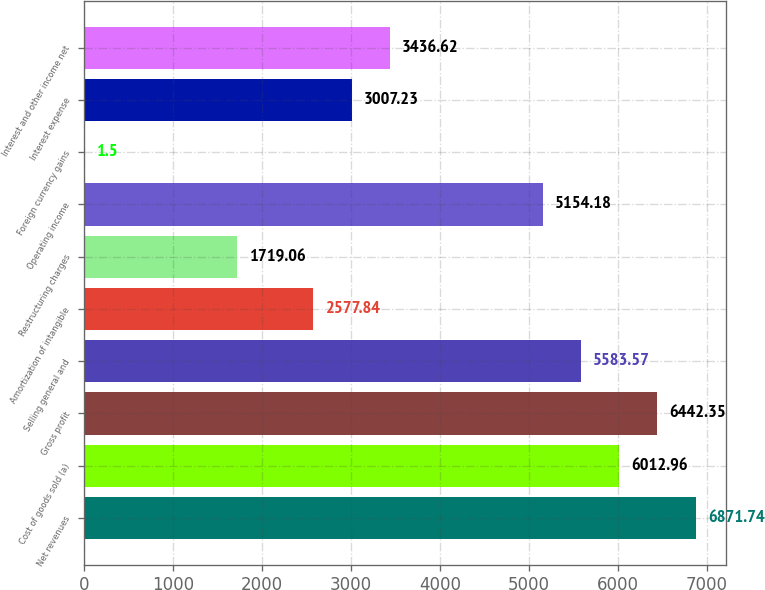Convert chart. <chart><loc_0><loc_0><loc_500><loc_500><bar_chart><fcel>Net revenues<fcel>Cost of goods sold (a)<fcel>Gross profit<fcel>Selling general and<fcel>Amortization of intangible<fcel>Restructuring charges<fcel>Operating income<fcel>Foreign currency gains<fcel>Interest expense<fcel>Interest and other income net<nl><fcel>6871.74<fcel>6012.96<fcel>6442.35<fcel>5583.57<fcel>2577.84<fcel>1719.06<fcel>5154.18<fcel>1.5<fcel>3007.23<fcel>3436.62<nl></chart> 